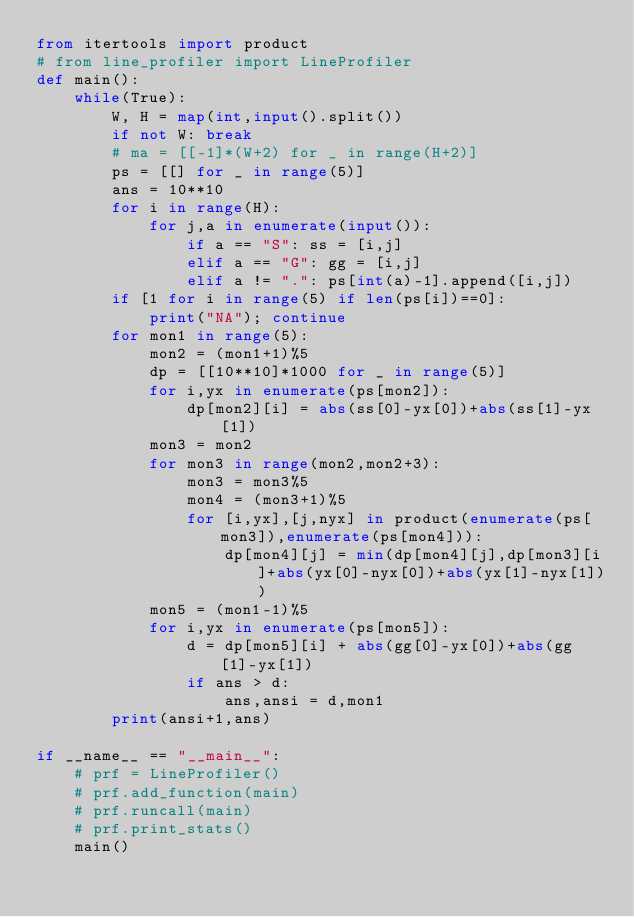Convert code to text. <code><loc_0><loc_0><loc_500><loc_500><_Python_>from itertools import product
# from line_profiler import LineProfiler
def main():
    while(True):
        W, H = map(int,input().split())
        if not W: break
        # ma = [[-1]*(W+2) for _ in range(H+2)]
        ps = [[] for _ in range(5)]
        ans = 10**10
        for i in range(H):
            for j,a in enumerate(input()):
                if a == "S": ss = [i,j]
                elif a == "G": gg = [i,j]
                elif a != ".": ps[int(a)-1].append([i,j])
        if [1 for i in range(5) if len(ps[i])==0]:
            print("NA"); continue
        for mon1 in range(5):
            mon2 = (mon1+1)%5
            dp = [[10**10]*1000 for _ in range(5)]
            for i,yx in enumerate(ps[mon2]):
                dp[mon2][i] = abs(ss[0]-yx[0])+abs(ss[1]-yx[1])
            mon3 = mon2
            for mon3 in range(mon2,mon2+3):
                mon3 = mon3%5
                mon4 = (mon3+1)%5
                for [i,yx],[j,nyx] in product(enumerate(ps[mon3]),enumerate(ps[mon4])):
                    dp[mon4][j] = min(dp[mon4][j],dp[mon3][i]+abs(yx[0]-nyx[0])+abs(yx[1]-nyx[1]))
            mon5 = (mon1-1)%5
            for i,yx in enumerate(ps[mon5]):
                d = dp[mon5][i] + abs(gg[0]-yx[0])+abs(gg[1]-yx[1])
                if ans > d:
                    ans,ansi = d,mon1
        print(ansi+1,ans)

if __name__ == "__main__":
    # prf = LineProfiler()
    # prf.add_function(main)
    # prf.runcall(main)
    # prf.print_stats()
    main()
</code> 